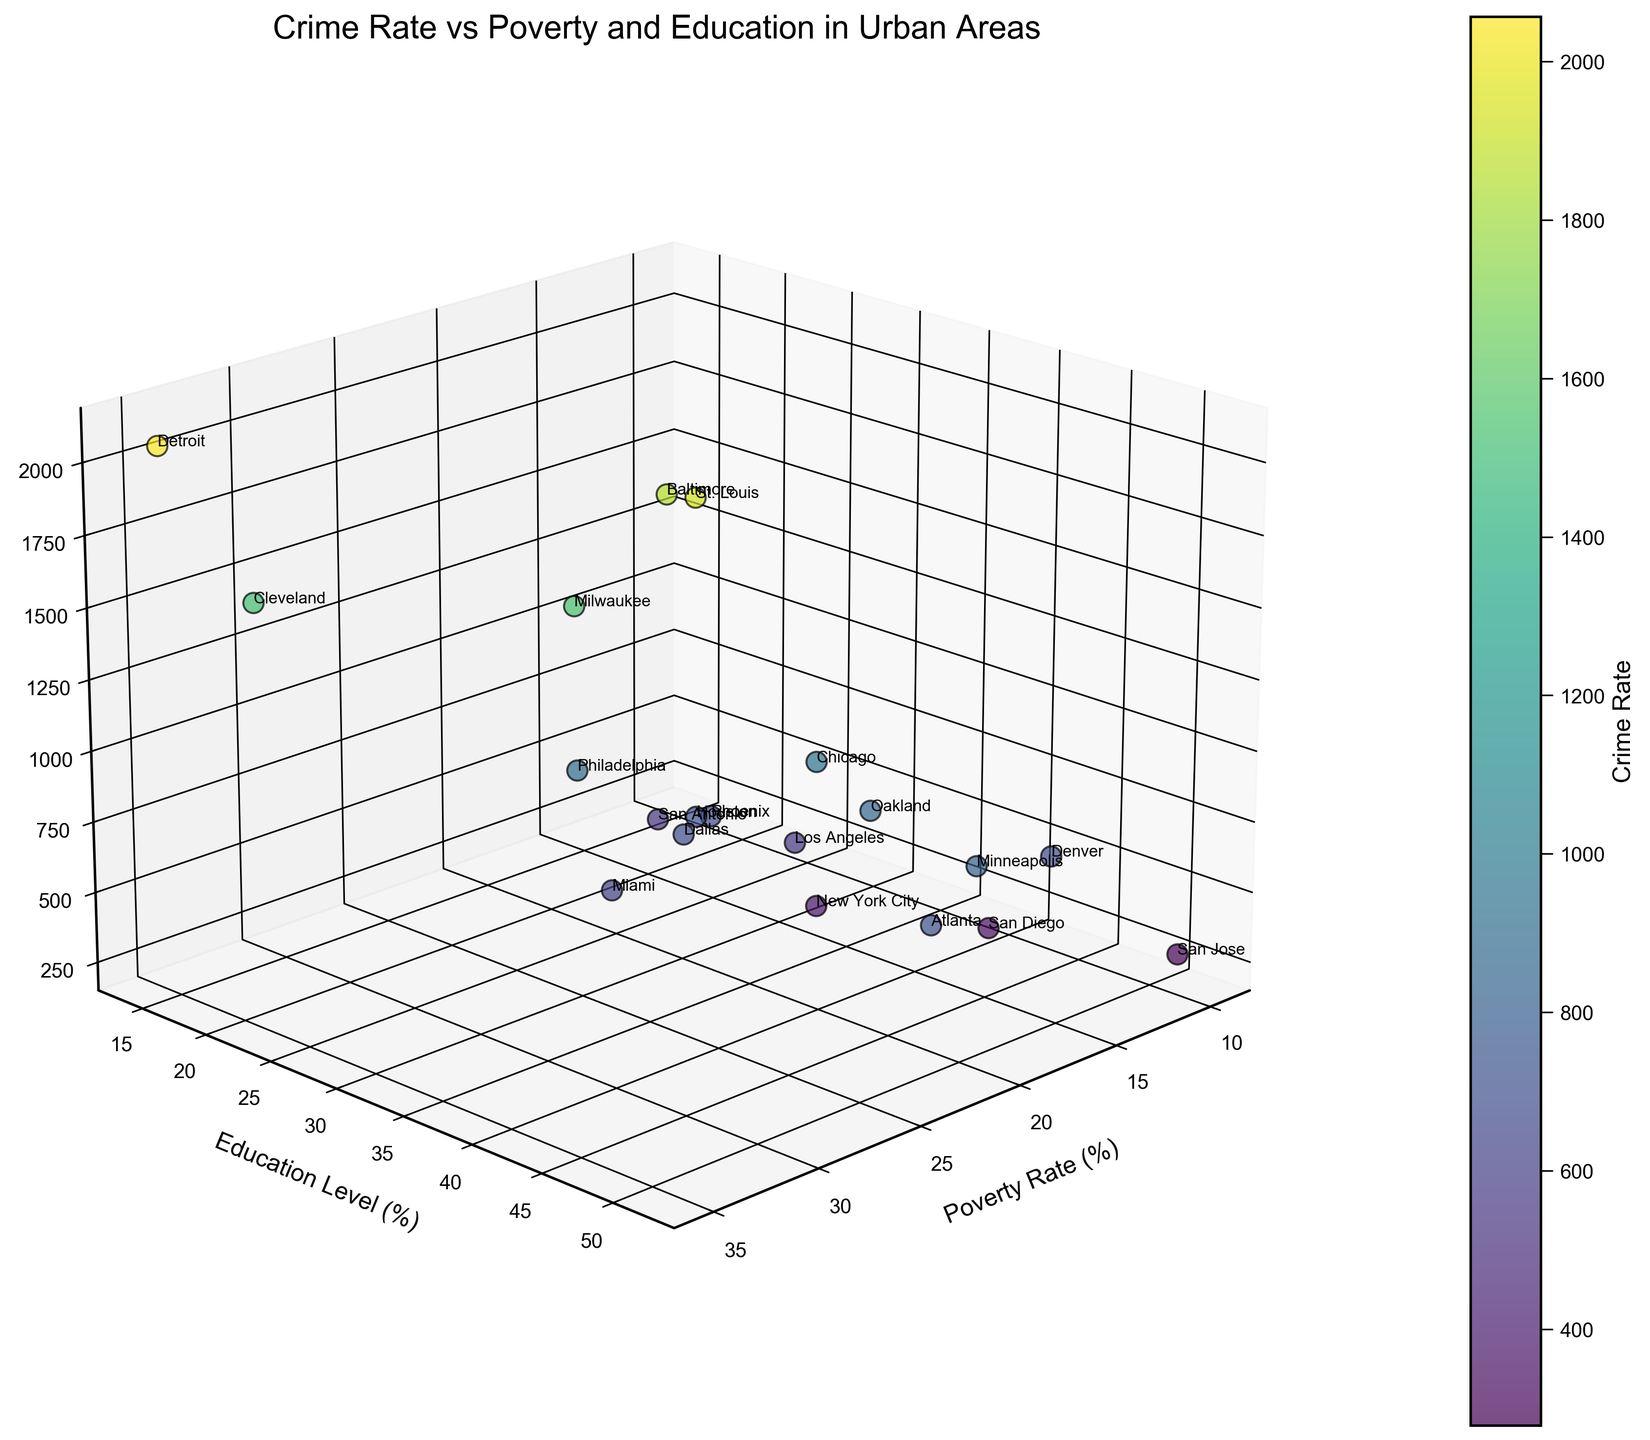What is the title of the 3D scatter plot? The title is displayed at the top of the figure and provides a summary of what the plot is about. The title in this figure is: "Crime Rate vs Poverty and Education in Urban Areas".
Answer: Crime Rate vs Poverty and Education in Urban Areas What are the x-axis, y-axis, and z-axis labels in the plot? The labels describe the variables represented by each axis in the 3D plot. From the figure: the x-axis label is “Poverty Rate (%)”, the y-axis label is “Education Level (%)”, and the z-axis label is “Crime Rate (per 100,000)”.
Answer: Poverty Rate (%), Education Level (%), Crime Rate (per 100,000) Which city has the highest crime rate according to the plot? By looking at the z-axis (Crime Rate), identify the city with the highest position in the 3D scatter plot. Detroit has the highest z-value, indicating the highest crime rate among the cities shown.
Answer: Detroit What is the relationship between the poverty rate and education level for San Jose? Locate San Jose in the plot and read its x (Poverty Rate) and y (Education Level) coordinates. San Jose has a poverty rate of 9.7% and an education level of 51.5%.
Answer: Poverty Rate: 9.7%, Education Level: 51.5% How does the crime rate of Miami compare to that of St. Louis? To compare, find Miami and St. Louis in the plot. St. Louis has a higher crime rate (higher z value) compared to Miami. Specifically, St. Louis's crime rate is 1927.4, while Miami's is 607.8.
Answer: St. Louis has a higher crime rate than Miami What can you say about the crime rate relative to education levels in San Diego and Cleveland? Identify both cities in the plot. San Diego has a higher education level (43.6%) and a lower crime rate (339.4) compared to Cleveland with lower education level (17.5%) and a higher crime rate (1516.3). This suggests an inverse relationship between education and crime rate for these cities.
Answer: San Diego has higher education and lower crime rate compared to Cleveland Which city has the lowest crime rate, and what are its poverty and education levels? Locate the city on the plot with the smallest z value which represents the crime rate. San Jose has the lowest crime rate (278.6). Its poverty rate is 9.7% and education level is 51.5%.
Answer: San Jose; Poverty Rate: 9.7%, Education Level: 51.5% Does higher poverty generally correlate with higher crime rates in these urban areas? By observing the overall trend in the plot, cities with higher poverty rates (higher x values) like Detroit, Baltimore, and Milwaukee tend to have higher crime rates, indicating a positive correlation between poverty and crime rates.
Answer: Generally, yes What is the crime rate for New York City, and how does it compare to the average crime rate of all cities? Locate New York City and note its z value for the crime rate (375.2). Calculate the average crime rate of all cities from the data provided. The average crime rate = sum of all crime rates/number of cities = 15388.1/19 ≈ 810.9. New York City's crime rate (375.2) is significantly lower than the average.
Answer: 375.2; Lower than the average Which city has a higher education level but a lower crime rate than Chicago? Identify cities with higher education level (y) than Chicago (37.5%) but with lower crime rate (z) than Chicago (943.2). San Diego (education: 43.6%, crime: 339.4) and San Jose (education: 51.5%, crime: 278.6) both meet these criteria.
Answer: San Diego, San Jose 